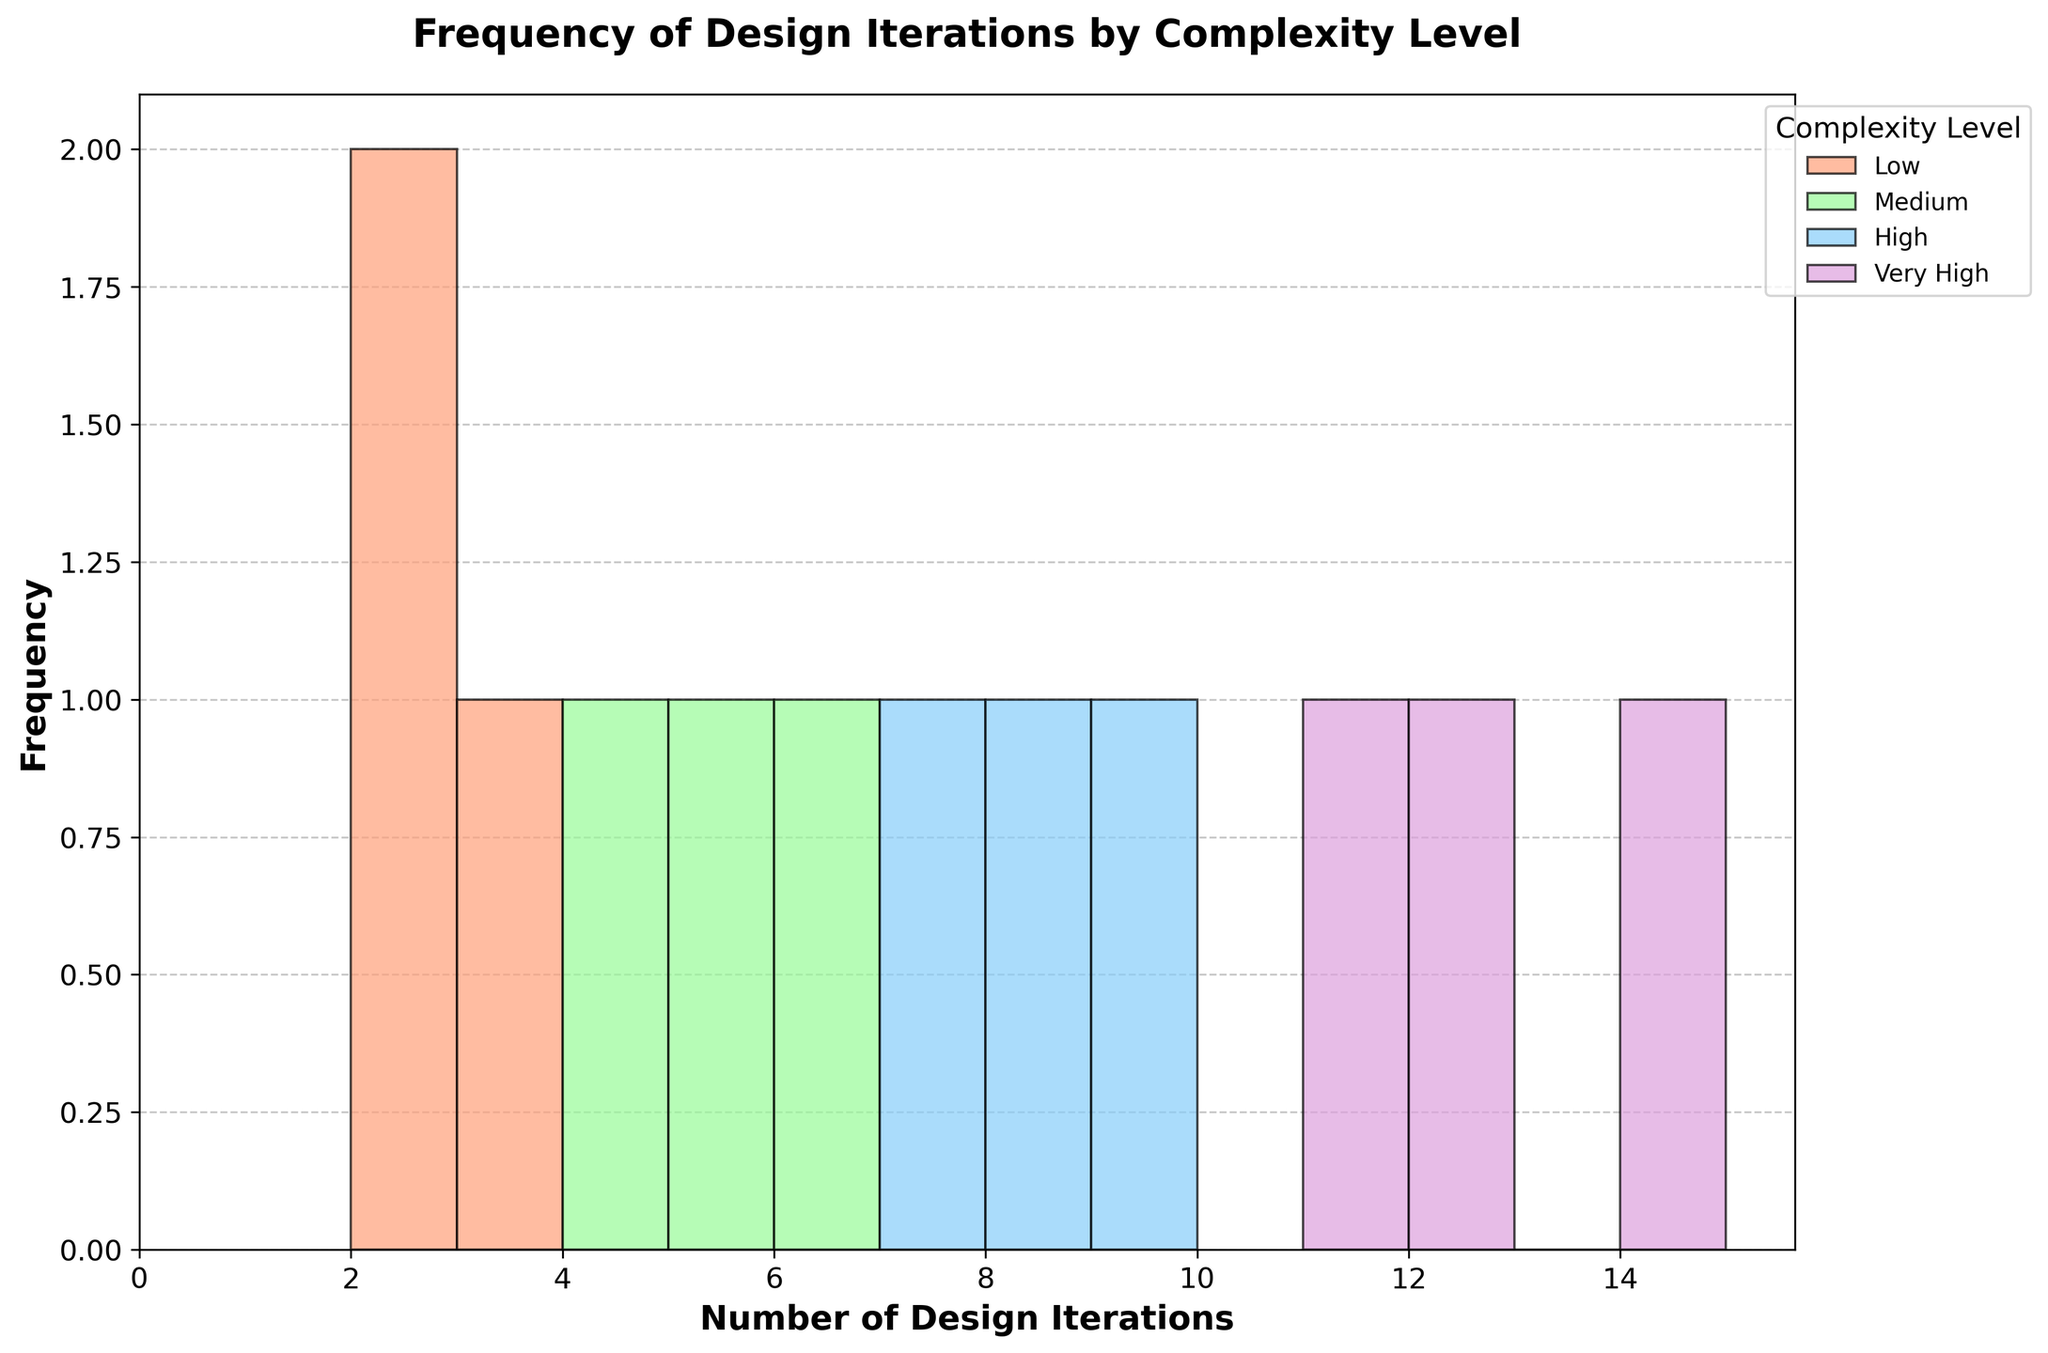What is the title of the figure? The title of the figure is usually displayed at the top of the chart. It provides a summary of what the chart is about. In this case, it is "Frequency of Design Iterations by Complexity Level".
Answer: Frequency of Design Iterations by Complexity Level What is the highest number of design iterations represented in the chart? Look at the x-axis, which represents the number of design iterations. The highest number visible on the x-axis is 14.
Answer: 14 Which complexity level has the highest design iterations? You need to check the individual bars for each complexity level to see which has the highest value on the x-axis (number of design iterations). "Very High" complexity has the highest value at 14.
Answer: Very High Compare the frequency of design iterations for 'Low' and 'Medium' complexity levels. Which has more iterated designs overall? Sum the frequencies of the histogram bars for 'Low' and 'Medium' complexity levels. 'Low' has 2 + 3 + 2 = 7, and 'Medium' has 5 + 6 + 4 = 15.
Answer: Medium Which two products from the 'Very High' complexity level have the closest number of design iterations? In the 'Very High' complexity level, compare Satellite Components (12), Nuclear Reactor Components (14), and Quantum Computing Hardware (11). Satellite Components (12) and Quantum Computing Hardware (11) are closest.
Answer: Satellite Components and Quantum Computing Hardware What is the total number of design iterations for all products in the 'High' complexity level? Sum the design iterations for Aerospace Parts (8), Medical Devices (9), and Robotic Systems (7). 8 + 9 + 7 = 24.
Answer: 24 How do the frequencies of design iterations for 'Low' complexity products compare to 'High' complexity products? Compare the histograms: 'Low' complexity has design iterations primarily at 2 and 3, 'High' complexity ranges from 7 to 9. 'High' complexity has a higher frequency and variation of design iterations.
Answer: High complexity has more and varied iterations Is there any complexity level where the number of design iterations does not overlap with any other complexity level? Check the ranges of design iterations for each complexity level. 'Very High' complexity (11, 12, 14) does not overlap with others.
Answer: Very High What is the most common number of design iterations for 'Medium' complexity? Check the histogram for 'Medium'. Each frequency of design iterations: 4, 5, 6. The most common is 6.
Answer: 6 